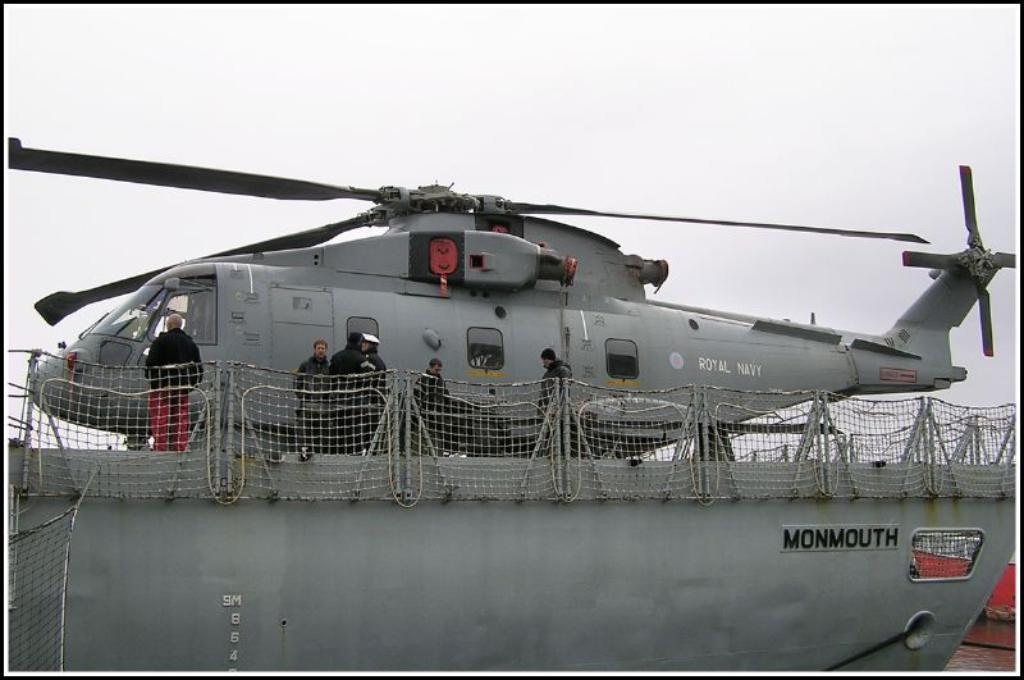Provide a one-sentence caption for the provided image. A military helicopter is parked on top of a ship called the Monmouth. 